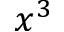Convert formula to latex. <formula><loc_0><loc_0><loc_500><loc_500>x ^ { 3 }</formula> 